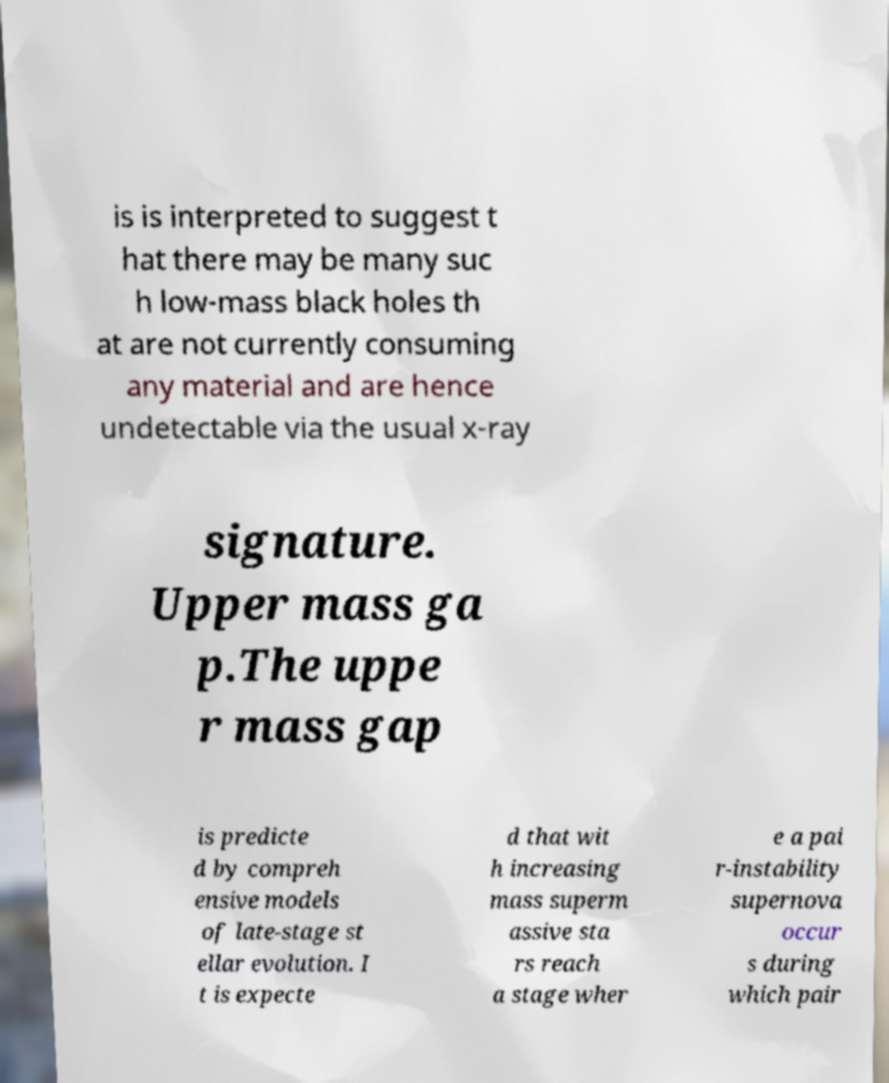Could you extract and type out the text from this image? is is interpreted to suggest t hat there may be many suc h low-mass black holes th at are not currently consuming any material and are hence undetectable via the usual x-ray signature. Upper mass ga p.The uppe r mass gap is predicte d by compreh ensive models of late-stage st ellar evolution. I t is expecte d that wit h increasing mass superm assive sta rs reach a stage wher e a pai r-instability supernova occur s during which pair 